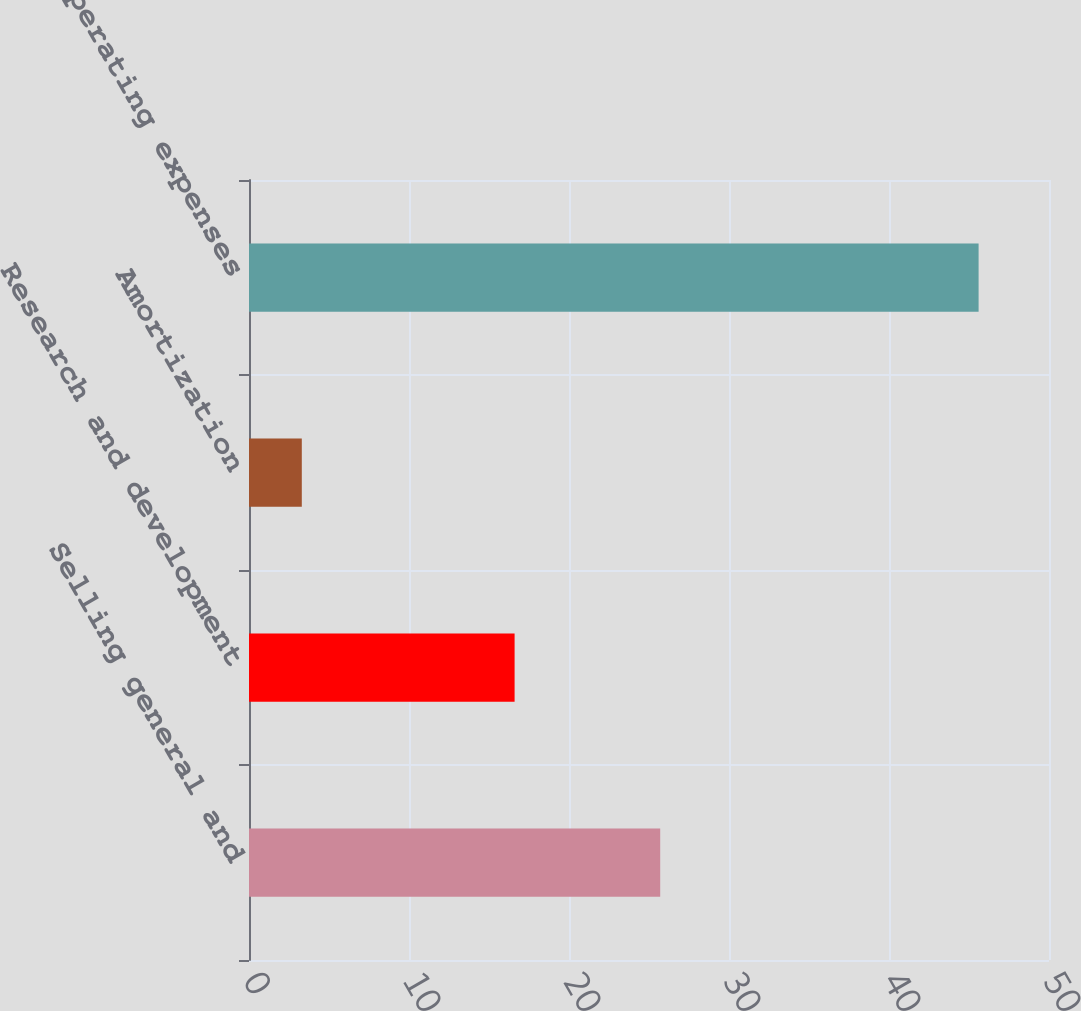Convert chart. <chart><loc_0><loc_0><loc_500><loc_500><bar_chart><fcel>Selling general and<fcel>Research and development<fcel>Amortization<fcel>Total operating expenses<nl><fcel>25.7<fcel>16.6<fcel>3.3<fcel>45.6<nl></chart> 